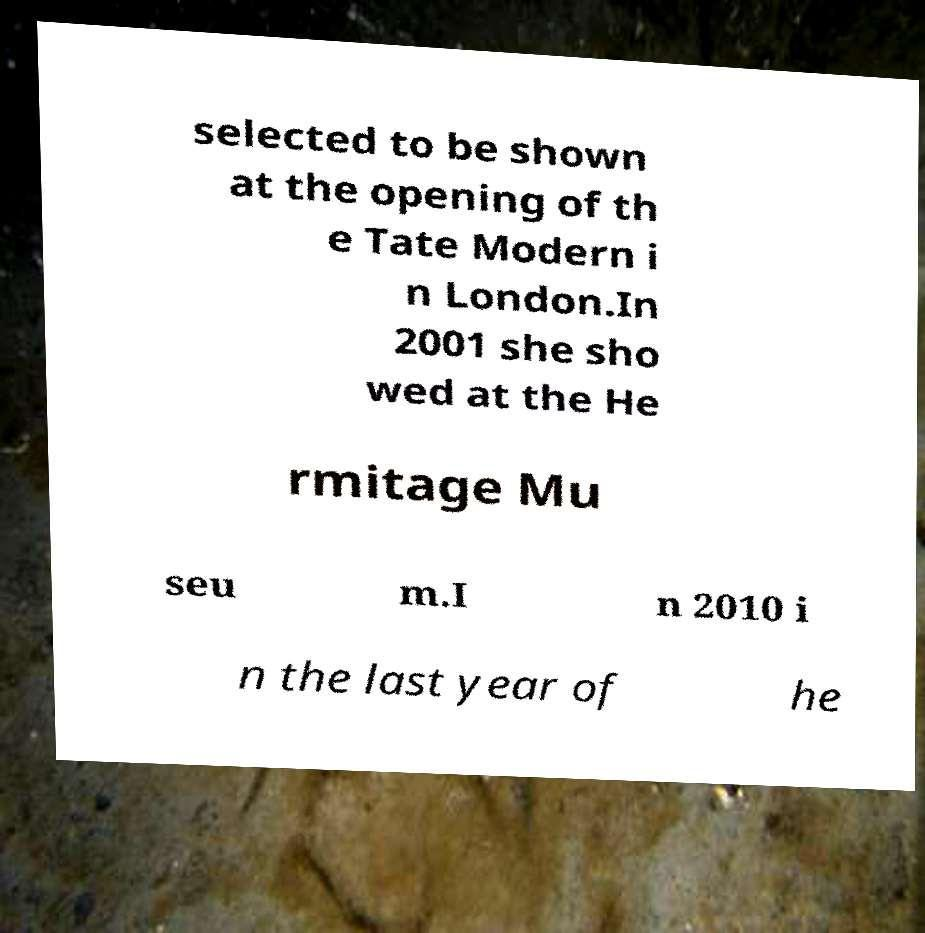There's text embedded in this image that I need extracted. Can you transcribe it verbatim? selected to be shown at the opening of th e Tate Modern i n London.In 2001 she sho wed at the He rmitage Mu seu m.I n 2010 i n the last year of he 